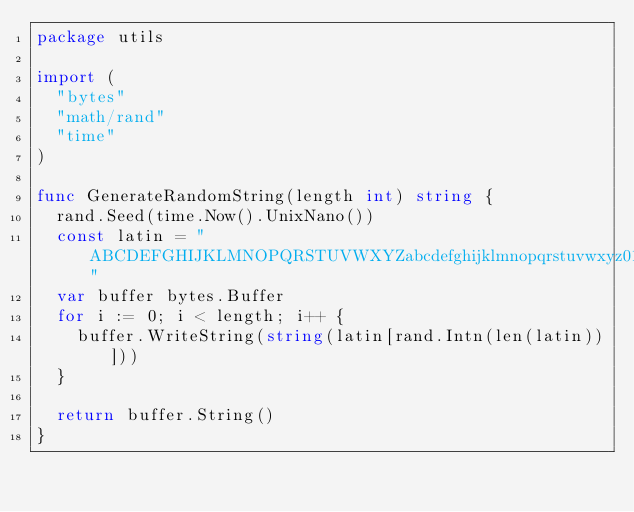Convert code to text. <code><loc_0><loc_0><loc_500><loc_500><_Go_>package utils

import (
	"bytes"
	"math/rand"
	"time"
)

func GenerateRandomString(length int) string {
	rand.Seed(time.Now().UnixNano())
	const latin = "ABCDEFGHIJKLMNOPQRSTUVWXYZabcdefghijklmnopqrstuvwxyz01233456789"
	var buffer bytes.Buffer
	for i := 0; i < length; i++ {
		buffer.WriteString(string(latin[rand.Intn(len(latin))]))
	}

	return buffer.String()
}
</code> 